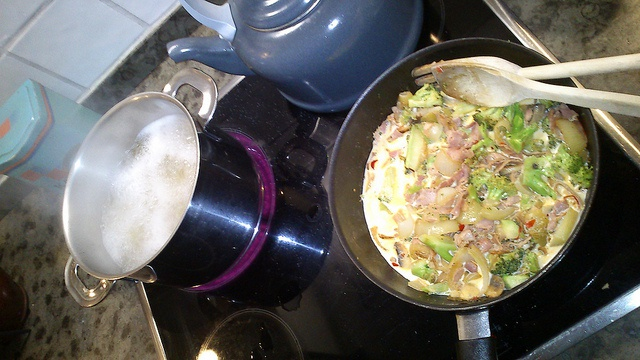Describe the objects in this image and their specific colors. I can see bowl in darkgray, khaki, tan, black, and olive tones, spoon in darkgray, beige, and tan tones, broccoli in darkgray, olive, and khaki tones, broccoli in darkgray and olive tones, and broccoli in darkgray, olive, and khaki tones in this image. 